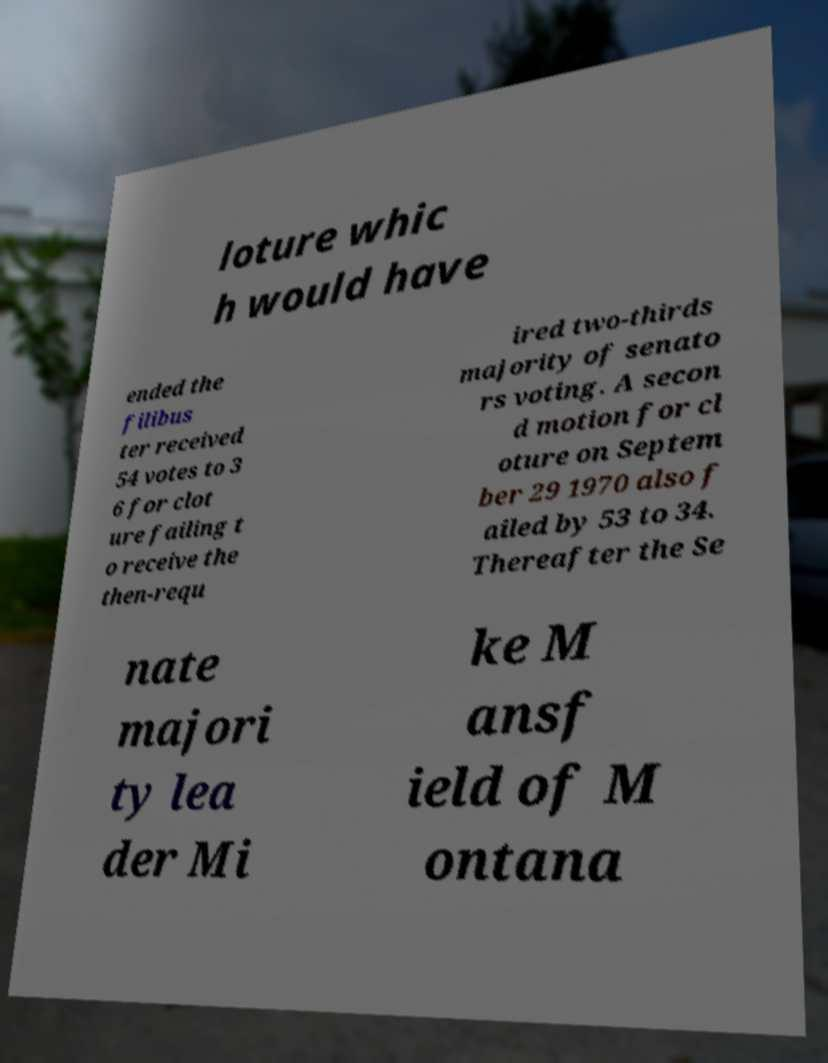Please read and relay the text visible in this image. What does it say? loture whic h would have ended the filibus ter received 54 votes to 3 6 for clot ure failing t o receive the then-requ ired two-thirds majority of senato rs voting. A secon d motion for cl oture on Septem ber 29 1970 also f ailed by 53 to 34. Thereafter the Se nate majori ty lea der Mi ke M ansf ield of M ontana 